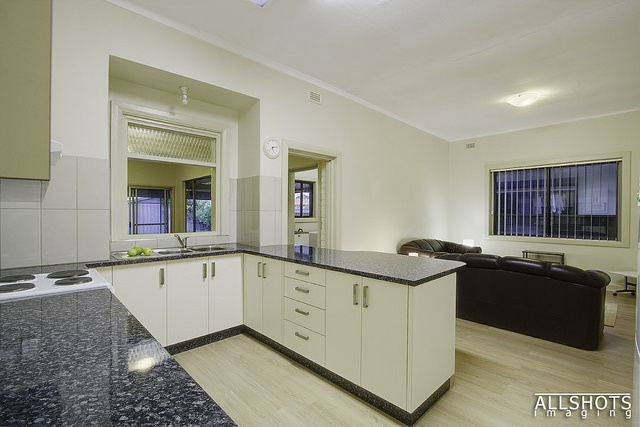Describe the objects in this image and their specific colors. I can see couch in gray and black tones, sink in gray, darkgray, and black tones, clock in gray, lightgray, and darkgray tones, apple in gray and olive tones, and orange in gray, khaki, and olive tones in this image. 